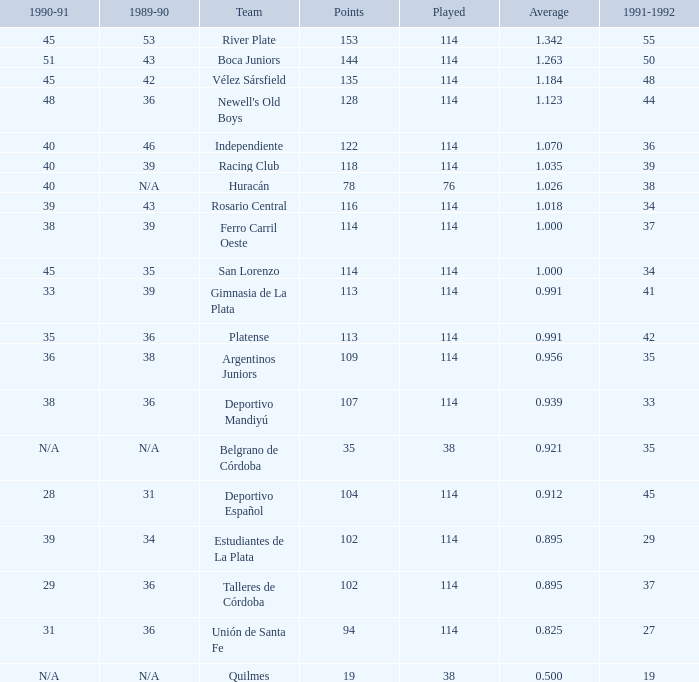How much 1991-1992 has a Team of gimnasia de la plata, and more than 113 points? 0.0. 